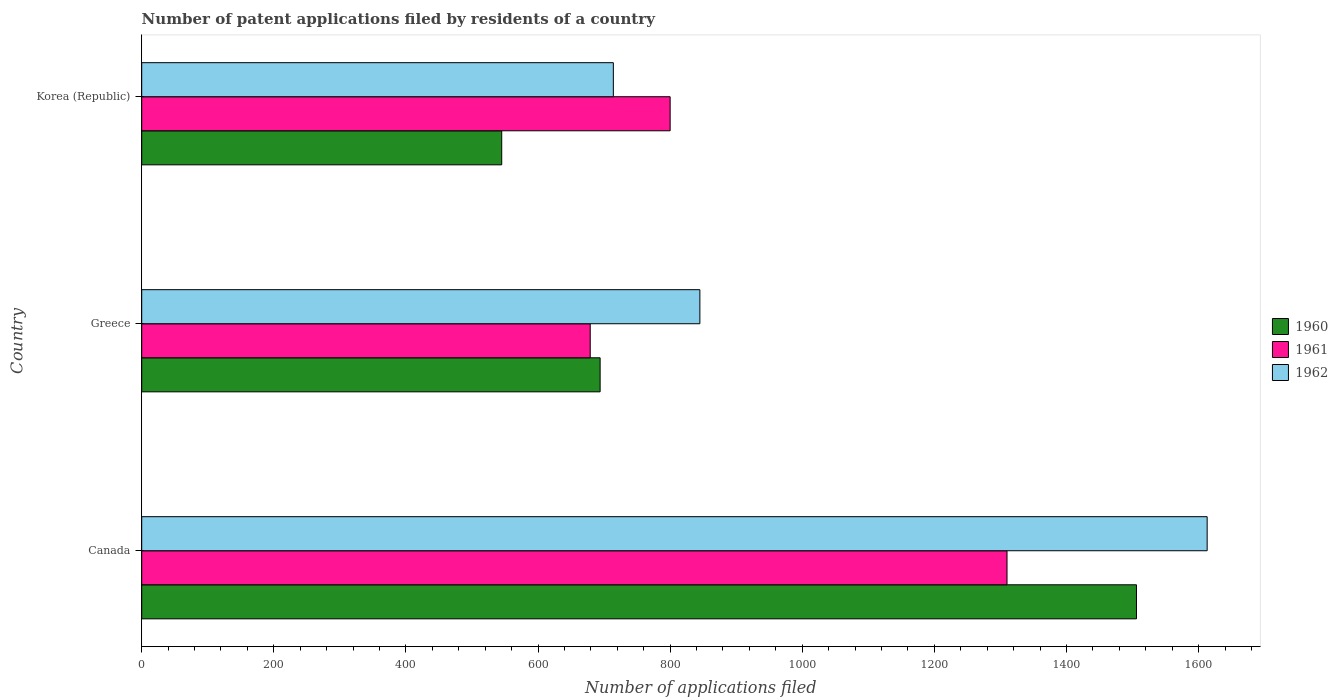How many groups of bars are there?
Make the answer very short. 3. Are the number of bars on each tick of the Y-axis equal?
Keep it short and to the point. Yes. How many bars are there on the 3rd tick from the top?
Make the answer very short. 3. How many bars are there on the 1st tick from the bottom?
Ensure brevity in your answer.  3. What is the number of applications filed in 1960 in Korea (Republic)?
Offer a very short reply. 545. Across all countries, what is the maximum number of applications filed in 1960?
Your answer should be compact. 1506. Across all countries, what is the minimum number of applications filed in 1961?
Give a very brief answer. 679. What is the total number of applications filed in 1962 in the graph?
Your answer should be very brief. 3172. What is the difference between the number of applications filed in 1962 in Canada and that in Greece?
Your answer should be compact. 768. What is the average number of applications filed in 1961 per country?
Ensure brevity in your answer.  929.67. What is the difference between the number of applications filed in 1961 and number of applications filed in 1962 in Greece?
Offer a terse response. -166. What is the ratio of the number of applications filed in 1960 in Canada to that in Greece?
Offer a terse response. 2.17. Is the difference between the number of applications filed in 1961 in Canada and Greece greater than the difference between the number of applications filed in 1962 in Canada and Greece?
Make the answer very short. No. What is the difference between the highest and the second highest number of applications filed in 1961?
Offer a terse response. 510. What is the difference between the highest and the lowest number of applications filed in 1962?
Your response must be concise. 899. In how many countries, is the number of applications filed in 1961 greater than the average number of applications filed in 1961 taken over all countries?
Your response must be concise. 1. Is the sum of the number of applications filed in 1962 in Canada and Greece greater than the maximum number of applications filed in 1961 across all countries?
Your answer should be very brief. Yes. What does the 3rd bar from the top in Canada represents?
Your answer should be very brief. 1960. What does the 2nd bar from the bottom in Greece represents?
Your answer should be very brief. 1961. How many bars are there?
Give a very brief answer. 9. What is the difference between two consecutive major ticks on the X-axis?
Keep it short and to the point. 200. Are the values on the major ticks of X-axis written in scientific E-notation?
Ensure brevity in your answer.  No. Where does the legend appear in the graph?
Give a very brief answer. Center right. How are the legend labels stacked?
Your response must be concise. Vertical. What is the title of the graph?
Offer a very short reply. Number of patent applications filed by residents of a country. What is the label or title of the X-axis?
Provide a succinct answer. Number of applications filed. What is the Number of applications filed in 1960 in Canada?
Offer a very short reply. 1506. What is the Number of applications filed of 1961 in Canada?
Your answer should be compact. 1310. What is the Number of applications filed of 1962 in Canada?
Your answer should be very brief. 1613. What is the Number of applications filed in 1960 in Greece?
Offer a terse response. 694. What is the Number of applications filed of 1961 in Greece?
Give a very brief answer. 679. What is the Number of applications filed of 1962 in Greece?
Your response must be concise. 845. What is the Number of applications filed of 1960 in Korea (Republic)?
Your answer should be compact. 545. What is the Number of applications filed in 1961 in Korea (Republic)?
Your response must be concise. 800. What is the Number of applications filed in 1962 in Korea (Republic)?
Give a very brief answer. 714. Across all countries, what is the maximum Number of applications filed in 1960?
Your answer should be compact. 1506. Across all countries, what is the maximum Number of applications filed of 1961?
Provide a short and direct response. 1310. Across all countries, what is the maximum Number of applications filed of 1962?
Offer a very short reply. 1613. Across all countries, what is the minimum Number of applications filed in 1960?
Provide a short and direct response. 545. Across all countries, what is the minimum Number of applications filed of 1961?
Give a very brief answer. 679. Across all countries, what is the minimum Number of applications filed in 1962?
Provide a succinct answer. 714. What is the total Number of applications filed in 1960 in the graph?
Make the answer very short. 2745. What is the total Number of applications filed in 1961 in the graph?
Your response must be concise. 2789. What is the total Number of applications filed in 1962 in the graph?
Give a very brief answer. 3172. What is the difference between the Number of applications filed of 1960 in Canada and that in Greece?
Your answer should be compact. 812. What is the difference between the Number of applications filed of 1961 in Canada and that in Greece?
Ensure brevity in your answer.  631. What is the difference between the Number of applications filed of 1962 in Canada and that in Greece?
Offer a terse response. 768. What is the difference between the Number of applications filed in 1960 in Canada and that in Korea (Republic)?
Provide a succinct answer. 961. What is the difference between the Number of applications filed in 1961 in Canada and that in Korea (Republic)?
Give a very brief answer. 510. What is the difference between the Number of applications filed of 1962 in Canada and that in Korea (Republic)?
Your answer should be very brief. 899. What is the difference between the Number of applications filed of 1960 in Greece and that in Korea (Republic)?
Your response must be concise. 149. What is the difference between the Number of applications filed of 1961 in Greece and that in Korea (Republic)?
Ensure brevity in your answer.  -121. What is the difference between the Number of applications filed in 1962 in Greece and that in Korea (Republic)?
Your response must be concise. 131. What is the difference between the Number of applications filed in 1960 in Canada and the Number of applications filed in 1961 in Greece?
Make the answer very short. 827. What is the difference between the Number of applications filed in 1960 in Canada and the Number of applications filed in 1962 in Greece?
Provide a succinct answer. 661. What is the difference between the Number of applications filed in 1961 in Canada and the Number of applications filed in 1962 in Greece?
Provide a succinct answer. 465. What is the difference between the Number of applications filed of 1960 in Canada and the Number of applications filed of 1961 in Korea (Republic)?
Your answer should be compact. 706. What is the difference between the Number of applications filed of 1960 in Canada and the Number of applications filed of 1962 in Korea (Republic)?
Your response must be concise. 792. What is the difference between the Number of applications filed in 1961 in Canada and the Number of applications filed in 1962 in Korea (Republic)?
Offer a terse response. 596. What is the difference between the Number of applications filed in 1960 in Greece and the Number of applications filed in 1961 in Korea (Republic)?
Your answer should be very brief. -106. What is the difference between the Number of applications filed in 1960 in Greece and the Number of applications filed in 1962 in Korea (Republic)?
Ensure brevity in your answer.  -20. What is the difference between the Number of applications filed in 1961 in Greece and the Number of applications filed in 1962 in Korea (Republic)?
Provide a succinct answer. -35. What is the average Number of applications filed in 1960 per country?
Provide a succinct answer. 915. What is the average Number of applications filed in 1961 per country?
Provide a succinct answer. 929.67. What is the average Number of applications filed in 1962 per country?
Offer a very short reply. 1057.33. What is the difference between the Number of applications filed of 1960 and Number of applications filed of 1961 in Canada?
Your answer should be very brief. 196. What is the difference between the Number of applications filed in 1960 and Number of applications filed in 1962 in Canada?
Keep it short and to the point. -107. What is the difference between the Number of applications filed of 1961 and Number of applications filed of 1962 in Canada?
Your answer should be very brief. -303. What is the difference between the Number of applications filed in 1960 and Number of applications filed in 1962 in Greece?
Your answer should be compact. -151. What is the difference between the Number of applications filed of 1961 and Number of applications filed of 1962 in Greece?
Make the answer very short. -166. What is the difference between the Number of applications filed of 1960 and Number of applications filed of 1961 in Korea (Republic)?
Make the answer very short. -255. What is the difference between the Number of applications filed of 1960 and Number of applications filed of 1962 in Korea (Republic)?
Your response must be concise. -169. What is the ratio of the Number of applications filed of 1960 in Canada to that in Greece?
Your response must be concise. 2.17. What is the ratio of the Number of applications filed of 1961 in Canada to that in Greece?
Give a very brief answer. 1.93. What is the ratio of the Number of applications filed in 1962 in Canada to that in Greece?
Make the answer very short. 1.91. What is the ratio of the Number of applications filed of 1960 in Canada to that in Korea (Republic)?
Your response must be concise. 2.76. What is the ratio of the Number of applications filed in 1961 in Canada to that in Korea (Republic)?
Your response must be concise. 1.64. What is the ratio of the Number of applications filed of 1962 in Canada to that in Korea (Republic)?
Your response must be concise. 2.26. What is the ratio of the Number of applications filed of 1960 in Greece to that in Korea (Republic)?
Provide a short and direct response. 1.27. What is the ratio of the Number of applications filed in 1961 in Greece to that in Korea (Republic)?
Keep it short and to the point. 0.85. What is the ratio of the Number of applications filed in 1962 in Greece to that in Korea (Republic)?
Offer a terse response. 1.18. What is the difference between the highest and the second highest Number of applications filed of 1960?
Offer a very short reply. 812. What is the difference between the highest and the second highest Number of applications filed in 1961?
Keep it short and to the point. 510. What is the difference between the highest and the second highest Number of applications filed in 1962?
Provide a succinct answer. 768. What is the difference between the highest and the lowest Number of applications filed in 1960?
Offer a terse response. 961. What is the difference between the highest and the lowest Number of applications filed of 1961?
Ensure brevity in your answer.  631. What is the difference between the highest and the lowest Number of applications filed of 1962?
Your response must be concise. 899. 